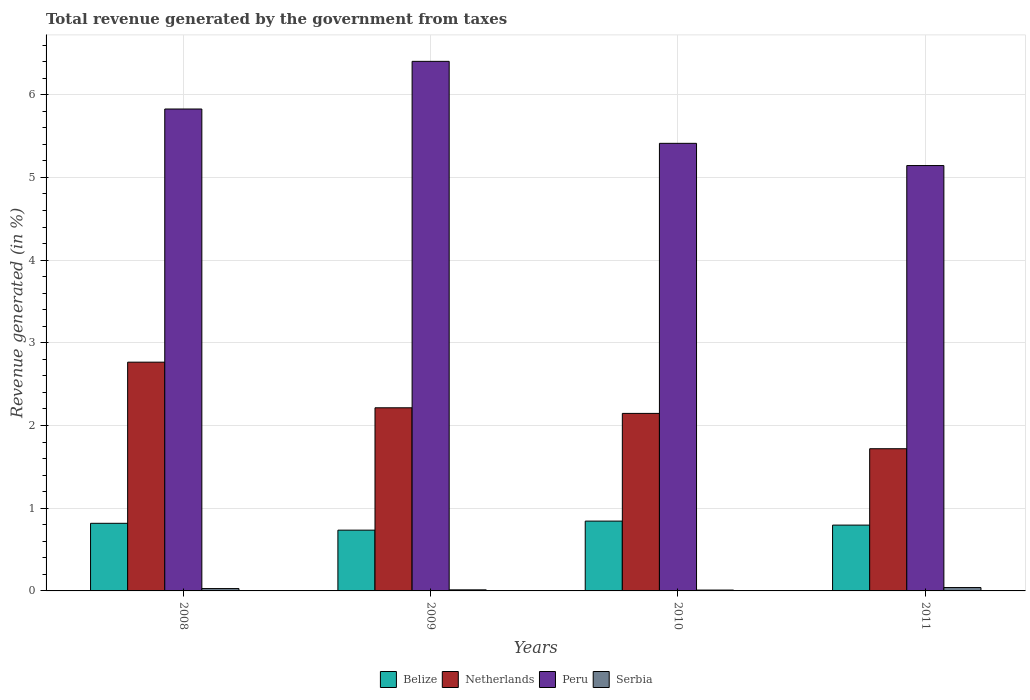How many different coloured bars are there?
Provide a short and direct response. 4. How many groups of bars are there?
Provide a succinct answer. 4. How many bars are there on the 1st tick from the left?
Provide a succinct answer. 4. What is the label of the 2nd group of bars from the left?
Make the answer very short. 2009. What is the total revenue generated in Serbia in 2008?
Provide a short and direct response. 0.03. Across all years, what is the maximum total revenue generated in Peru?
Provide a succinct answer. 6.4. Across all years, what is the minimum total revenue generated in Peru?
Offer a very short reply. 5.14. What is the total total revenue generated in Peru in the graph?
Your answer should be compact. 22.78. What is the difference between the total revenue generated in Netherlands in 2009 and that in 2011?
Provide a succinct answer. 0.49. What is the difference between the total revenue generated in Belize in 2008 and the total revenue generated in Netherlands in 2009?
Your answer should be compact. -1.4. What is the average total revenue generated in Serbia per year?
Your answer should be very brief. 0.02. In the year 2009, what is the difference between the total revenue generated in Serbia and total revenue generated in Belize?
Offer a terse response. -0.72. In how many years, is the total revenue generated in Belize greater than 6.4 %?
Your response must be concise. 0. What is the ratio of the total revenue generated in Belize in 2008 to that in 2011?
Offer a terse response. 1.03. Is the difference between the total revenue generated in Serbia in 2009 and 2011 greater than the difference between the total revenue generated in Belize in 2009 and 2011?
Provide a succinct answer. Yes. What is the difference between the highest and the second highest total revenue generated in Peru?
Your response must be concise. 0.58. What is the difference between the highest and the lowest total revenue generated in Peru?
Make the answer very short. 1.26. In how many years, is the total revenue generated in Peru greater than the average total revenue generated in Peru taken over all years?
Keep it short and to the point. 2. Is the sum of the total revenue generated in Netherlands in 2008 and 2011 greater than the maximum total revenue generated in Peru across all years?
Your answer should be very brief. No. What does the 3rd bar from the left in 2011 represents?
Provide a succinct answer. Peru. What does the 1st bar from the right in 2009 represents?
Provide a succinct answer. Serbia. Is it the case that in every year, the sum of the total revenue generated in Serbia and total revenue generated in Peru is greater than the total revenue generated in Netherlands?
Provide a short and direct response. Yes. How many bars are there?
Provide a succinct answer. 16. Are all the bars in the graph horizontal?
Offer a very short reply. No. How many years are there in the graph?
Make the answer very short. 4. What is the difference between two consecutive major ticks on the Y-axis?
Your answer should be very brief. 1. Are the values on the major ticks of Y-axis written in scientific E-notation?
Your answer should be compact. No. Does the graph contain any zero values?
Give a very brief answer. No. How many legend labels are there?
Make the answer very short. 4. What is the title of the graph?
Ensure brevity in your answer.  Total revenue generated by the government from taxes. Does "Denmark" appear as one of the legend labels in the graph?
Ensure brevity in your answer.  No. What is the label or title of the X-axis?
Make the answer very short. Years. What is the label or title of the Y-axis?
Your answer should be compact. Revenue generated (in %). What is the Revenue generated (in %) of Belize in 2008?
Offer a very short reply. 0.82. What is the Revenue generated (in %) in Netherlands in 2008?
Provide a succinct answer. 2.77. What is the Revenue generated (in %) in Peru in 2008?
Offer a very short reply. 5.83. What is the Revenue generated (in %) of Serbia in 2008?
Ensure brevity in your answer.  0.03. What is the Revenue generated (in %) of Belize in 2009?
Your response must be concise. 0.73. What is the Revenue generated (in %) of Netherlands in 2009?
Your answer should be compact. 2.21. What is the Revenue generated (in %) of Peru in 2009?
Ensure brevity in your answer.  6.4. What is the Revenue generated (in %) of Serbia in 2009?
Give a very brief answer. 0.01. What is the Revenue generated (in %) in Belize in 2010?
Your answer should be very brief. 0.84. What is the Revenue generated (in %) in Netherlands in 2010?
Your answer should be very brief. 2.15. What is the Revenue generated (in %) of Peru in 2010?
Make the answer very short. 5.41. What is the Revenue generated (in %) of Serbia in 2010?
Give a very brief answer. 0.01. What is the Revenue generated (in %) in Belize in 2011?
Give a very brief answer. 0.8. What is the Revenue generated (in %) of Netherlands in 2011?
Your answer should be very brief. 1.72. What is the Revenue generated (in %) of Peru in 2011?
Give a very brief answer. 5.14. What is the Revenue generated (in %) of Serbia in 2011?
Give a very brief answer. 0.04. Across all years, what is the maximum Revenue generated (in %) in Belize?
Offer a very short reply. 0.84. Across all years, what is the maximum Revenue generated (in %) in Netherlands?
Provide a succinct answer. 2.77. Across all years, what is the maximum Revenue generated (in %) in Peru?
Ensure brevity in your answer.  6.4. Across all years, what is the maximum Revenue generated (in %) of Serbia?
Make the answer very short. 0.04. Across all years, what is the minimum Revenue generated (in %) in Belize?
Provide a succinct answer. 0.73. Across all years, what is the minimum Revenue generated (in %) of Netherlands?
Your answer should be compact. 1.72. Across all years, what is the minimum Revenue generated (in %) of Peru?
Your answer should be compact. 5.14. Across all years, what is the minimum Revenue generated (in %) in Serbia?
Give a very brief answer. 0.01. What is the total Revenue generated (in %) in Belize in the graph?
Provide a short and direct response. 3.19. What is the total Revenue generated (in %) in Netherlands in the graph?
Provide a short and direct response. 8.85. What is the total Revenue generated (in %) in Peru in the graph?
Your answer should be compact. 22.79. What is the total Revenue generated (in %) in Serbia in the graph?
Ensure brevity in your answer.  0.09. What is the difference between the Revenue generated (in %) of Belize in 2008 and that in 2009?
Your answer should be very brief. 0.08. What is the difference between the Revenue generated (in %) of Netherlands in 2008 and that in 2009?
Make the answer very short. 0.55. What is the difference between the Revenue generated (in %) in Peru in 2008 and that in 2009?
Make the answer very short. -0.58. What is the difference between the Revenue generated (in %) in Serbia in 2008 and that in 2009?
Provide a succinct answer. 0.02. What is the difference between the Revenue generated (in %) in Belize in 2008 and that in 2010?
Offer a very short reply. -0.03. What is the difference between the Revenue generated (in %) of Netherlands in 2008 and that in 2010?
Your answer should be compact. 0.62. What is the difference between the Revenue generated (in %) in Peru in 2008 and that in 2010?
Give a very brief answer. 0.42. What is the difference between the Revenue generated (in %) in Serbia in 2008 and that in 2010?
Make the answer very short. 0.02. What is the difference between the Revenue generated (in %) of Belize in 2008 and that in 2011?
Give a very brief answer. 0.02. What is the difference between the Revenue generated (in %) of Netherlands in 2008 and that in 2011?
Make the answer very short. 1.05. What is the difference between the Revenue generated (in %) of Peru in 2008 and that in 2011?
Ensure brevity in your answer.  0.68. What is the difference between the Revenue generated (in %) in Serbia in 2008 and that in 2011?
Provide a succinct answer. -0.01. What is the difference between the Revenue generated (in %) of Belize in 2009 and that in 2010?
Ensure brevity in your answer.  -0.11. What is the difference between the Revenue generated (in %) in Netherlands in 2009 and that in 2010?
Offer a terse response. 0.07. What is the difference between the Revenue generated (in %) in Serbia in 2009 and that in 2010?
Offer a very short reply. 0. What is the difference between the Revenue generated (in %) in Belize in 2009 and that in 2011?
Provide a succinct answer. -0.06. What is the difference between the Revenue generated (in %) in Netherlands in 2009 and that in 2011?
Your answer should be compact. 0.49. What is the difference between the Revenue generated (in %) of Peru in 2009 and that in 2011?
Offer a very short reply. 1.26. What is the difference between the Revenue generated (in %) in Serbia in 2009 and that in 2011?
Keep it short and to the point. -0.03. What is the difference between the Revenue generated (in %) in Belize in 2010 and that in 2011?
Offer a terse response. 0.05. What is the difference between the Revenue generated (in %) in Netherlands in 2010 and that in 2011?
Provide a succinct answer. 0.43. What is the difference between the Revenue generated (in %) of Peru in 2010 and that in 2011?
Offer a terse response. 0.27. What is the difference between the Revenue generated (in %) of Serbia in 2010 and that in 2011?
Your response must be concise. -0.03. What is the difference between the Revenue generated (in %) of Belize in 2008 and the Revenue generated (in %) of Netherlands in 2009?
Offer a very short reply. -1.4. What is the difference between the Revenue generated (in %) of Belize in 2008 and the Revenue generated (in %) of Peru in 2009?
Your answer should be very brief. -5.59. What is the difference between the Revenue generated (in %) of Belize in 2008 and the Revenue generated (in %) of Serbia in 2009?
Offer a terse response. 0.8. What is the difference between the Revenue generated (in %) in Netherlands in 2008 and the Revenue generated (in %) in Peru in 2009?
Offer a terse response. -3.64. What is the difference between the Revenue generated (in %) of Netherlands in 2008 and the Revenue generated (in %) of Serbia in 2009?
Keep it short and to the point. 2.75. What is the difference between the Revenue generated (in %) of Peru in 2008 and the Revenue generated (in %) of Serbia in 2009?
Keep it short and to the point. 5.81. What is the difference between the Revenue generated (in %) of Belize in 2008 and the Revenue generated (in %) of Netherlands in 2010?
Offer a terse response. -1.33. What is the difference between the Revenue generated (in %) in Belize in 2008 and the Revenue generated (in %) in Peru in 2010?
Give a very brief answer. -4.59. What is the difference between the Revenue generated (in %) in Belize in 2008 and the Revenue generated (in %) in Serbia in 2010?
Offer a terse response. 0.81. What is the difference between the Revenue generated (in %) in Netherlands in 2008 and the Revenue generated (in %) in Peru in 2010?
Make the answer very short. -2.65. What is the difference between the Revenue generated (in %) in Netherlands in 2008 and the Revenue generated (in %) in Serbia in 2010?
Give a very brief answer. 2.76. What is the difference between the Revenue generated (in %) in Peru in 2008 and the Revenue generated (in %) in Serbia in 2010?
Ensure brevity in your answer.  5.82. What is the difference between the Revenue generated (in %) of Belize in 2008 and the Revenue generated (in %) of Netherlands in 2011?
Keep it short and to the point. -0.9. What is the difference between the Revenue generated (in %) of Belize in 2008 and the Revenue generated (in %) of Peru in 2011?
Keep it short and to the point. -4.33. What is the difference between the Revenue generated (in %) of Belize in 2008 and the Revenue generated (in %) of Serbia in 2011?
Provide a succinct answer. 0.78. What is the difference between the Revenue generated (in %) of Netherlands in 2008 and the Revenue generated (in %) of Peru in 2011?
Keep it short and to the point. -2.38. What is the difference between the Revenue generated (in %) of Netherlands in 2008 and the Revenue generated (in %) of Serbia in 2011?
Provide a short and direct response. 2.73. What is the difference between the Revenue generated (in %) in Peru in 2008 and the Revenue generated (in %) in Serbia in 2011?
Give a very brief answer. 5.79. What is the difference between the Revenue generated (in %) of Belize in 2009 and the Revenue generated (in %) of Netherlands in 2010?
Offer a very short reply. -1.41. What is the difference between the Revenue generated (in %) of Belize in 2009 and the Revenue generated (in %) of Peru in 2010?
Ensure brevity in your answer.  -4.68. What is the difference between the Revenue generated (in %) of Belize in 2009 and the Revenue generated (in %) of Serbia in 2010?
Provide a succinct answer. 0.72. What is the difference between the Revenue generated (in %) of Netherlands in 2009 and the Revenue generated (in %) of Peru in 2010?
Provide a succinct answer. -3.2. What is the difference between the Revenue generated (in %) of Netherlands in 2009 and the Revenue generated (in %) of Serbia in 2010?
Give a very brief answer. 2.2. What is the difference between the Revenue generated (in %) of Peru in 2009 and the Revenue generated (in %) of Serbia in 2010?
Your answer should be compact. 6.39. What is the difference between the Revenue generated (in %) in Belize in 2009 and the Revenue generated (in %) in Netherlands in 2011?
Offer a very short reply. -0.98. What is the difference between the Revenue generated (in %) of Belize in 2009 and the Revenue generated (in %) of Peru in 2011?
Your response must be concise. -4.41. What is the difference between the Revenue generated (in %) of Belize in 2009 and the Revenue generated (in %) of Serbia in 2011?
Ensure brevity in your answer.  0.69. What is the difference between the Revenue generated (in %) of Netherlands in 2009 and the Revenue generated (in %) of Peru in 2011?
Your answer should be compact. -2.93. What is the difference between the Revenue generated (in %) in Netherlands in 2009 and the Revenue generated (in %) in Serbia in 2011?
Your answer should be compact. 2.17. What is the difference between the Revenue generated (in %) of Peru in 2009 and the Revenue generated (in %) of Serbia in 2011?
Keep it short and to the point. 6.36. What is the difference between the Revenue generated (in %) of Belize in 2010 and the Revenue generated (in %) of Netherlands in 2011?
Your answer should be very brief. -0.88. What is the difference between the Revenue generated (in %) of Belize in 2010 and the Revenue generated (in %) of Peru in 2011?
Provide a short and direct response. -4.3. What is the difference between the Revenue generated (in %) of Belize in 2010 and the Revenue generated (in %) of Serbia in 2011?
Provide a short and direct response. 0.8. What is the difference between the Revenue generated (in %) of Netherlands in 2010 and the Revenue generated (in %) of Peru in 2011?
Ensure brevity in your answer.  -3. What is the difference between the Revenue generated (in %) of Netherlands in 2010 and the Revenue generated (in %) of Serbia in 2011?
Your answer should be compact. 2.11. What is the difference between the Revenue generated (in %) in Peru in 2010 and the Revenue generated (in %) in Serbia in 2011?
Keep it short and to the point. 5.37. What is the average Revenue generated (in %) in Belize per year?
Your response must be concise. 0.8. What is the average Revenue generated (in %) in Netherlands per year?
Offer a very short reply. 2.21. What is the average Revenue generated (in %) in Peru per year?
Your answer should be very brief. 5.7. What is the average Revenue generated (in %) of Serbia per year?
Your answer should be very brief. 0.02. In the year 2008, what is the difference between the Revenue generated (in %) of Belize and Revenue generated (in %) of Netherlands?
Make the answer very short. -1.95. In the year 2008, what is the difference between the Revenue generated (in %) in Belize and Revenue generated (in %) in Peru?
Give a very brief answer. -5.01. In the year 2008, what is the difference between the Revenue generated (in %) in Belize and Revenue generated (in %) in Serbia?
Make the answer very short. 0.79. In the year 2008, what is the difference between the Revenue generated (in %) in Netherlands and Revenue generated (in %) in Peru?
Keep it short and to the point. -3.06. In the year 2008, what is the difference between the Revenue generated (in %) of Netherlands and Revenue generated (in %) of Serbia?
Your answer should be very brief. 2.74. In the year 2008, what is the difference between the Revenue generated (in %) in Peru and Revenue generated (in %) in Serbia?
Offer a very short reply. 5.8. In the year 2009, what is the difference between the Revenue generated (in %) in Belize and Revenue generated (in %) in Netherlands?
Your answer should be compact. -1.48. In the year 2009, what is the difference between the Revenue generated (in %) of Belize and Revenue generated (in %) of Peru?
Your response must be concise. -5.67. In the year 2009, what is the difference between the Revenue generated (in %) in Belize and Revenue generated (in %) in Serbia?
Keep it short and to the point. 0.72. In the year 2009, what is the difference between the Revenue generated (in %) in Netherlands and Revenue generated (in %) in Peru?
Offer a terse response. -4.19. In the year 2009, what is the difference between the Revenue generated (in %) of Netherlands and Revenue generated (in %) of Serbia?
Offer a terse response. 2.2. In the year 2009, what is the difference between the Revenue generated (in %) of Peru and Revenue generated (in %) of Serbia?
Provide a short and direct response. 6.39. In the year 2010, what is the difference between the Revenue generated (in %) in Belize and Revenue generated (in %) in Netherlands?
Ensure brevity in your answer.  -1.3. In the year 2010, what is the difference between the Revenue generated (in %) of Belize and Revenue generated (in %) of Peru?
Your answer should be compact. -4.57. In the year 2010, what is the difference between the Revenue generated (in %) of Belize and Revenue generated (in %) of Serbia?
Your response must be concise. 0.83. In the year 2010, what is the difference between the Revenue generated (in %) of Netherlands and Revenue generated (in %) of Peru?
Keep it short and to the point. -3.27. In the year 2010, what is the difference between the Revenue generated (in %) of Netherlands and Revenue generated (in %) of Serbia?
Your answer should be very brief. 2.14. In the year 2010, what is the difference between the Revenue generated (in %) in Peru and Revenue generated (in %) in Serbia?
Ensure brevity in your answer.  5.4. In the year 2011, what is the difference between the Revenue generated (in %) of Belize and Revenue generated (in %) of Netherlands?
Your answer should be very brief. -0.92. In the year 2011, what is the difference between the Revenue generated (in %) of Belize and Revenue generated (in %) of Peru?
Your response must be concise. -4.35. In the year 2011, what is the difference between the Revenue generated (in %) in Belize and Revenue generated (in %) in Serbia?
Keep it short and to the point. 0.76. In the year 2011, what is the difference between the Revenue generated (in %) in Netherlands and Revenue generated (in %) in Peru?
Provide a succinct answer. -3.42. In the year 2011, what is the difference between the Revenue generated (in %) in Netherlands and Revenue generated (in %) in Serbia?
Keep it short and to the point. 1.68. In the year 2011, what is the difference between the Revenue generated (in %) in Peru and Revenue generated (in %) in Serbia?
Your answer should be very brief. 5.1. What is the ratio of the Revenue generated (in %) in Belize in 2008 to that in 2009?
Provide a succinct answer. 1.11. What is the ratio of the Revenue generated (in %) in Netherlands in 2008 to that in 2009?
Offer a very short reply. 1.25. What is the ratio of the Revenue generated (in %) in Peru in 2008 to that in 2009?
Offer a terse response. 0.91. What is the ratio of the Revenue generated (in %) of Serbia in 2008 to that in 2009?
Your answer should be very brief. 2.18. What is the ratio of the Revenue generated (in %) in Belize in 2008 to that in 2010?
Provide a short and direct response. 0.97. What is the ratio of the Revenue generated (in %) in Netherlands in 2008 to that in 2010?
Provide a short and direct response. 1.29. What is the ratio of the Revenue generated (in %) in Peru in 2008 to that in 2010?
Ensure brevity in your answer.  1.08. What is the ratio of the Revenue generated (in %) in Serbia in 2008 to that in 2010?
Offer a terse response. 2.74. What is the ratio of the Revenue generated (in %) in Belize in 2008 to that in 2011?
Keep it short and to the point. 1.03. What is the ratio of the Revenue generated (in %) in Netherlands in 2008 to that in 2011?
Provide a short and direct response. 1.61. What is the ratio of the Revenue generated (in %) in Peru in 2008 to that in 2011?
Keep it short and to the point. 1.13. What is the ratio of the Revenue generated (in %) in Serbia in 2008 to that in 2011?
Your answer should be compact. 0.7. What is the ratio of the Revenue generated (in %) in Belize in 2009 to that in 2010?
Your answer should be compact. 0.87. What is the ratio of the Revenue generated (in %) of Netherlands in 2009 to that in 2010?
Offer a terse response. 1.03. What is the ratio of the Revenue generated (in %) in Peru in 2009 to that in 2010?
Your answer should be very brief. 1.18. What is the ratio of the Revenue generated (in %) in Serbia in 2009 to that in 2010?
Offer a very short reply. 1.25. What is the ratio of the Revenue generated (in %) of Netherlands in 2009 to that in 2011?
Offer a terse response. 1.29. What is the ratio of the Revenue generated (in %) of Peru in 2009 to that in 2011?
Ensure brevity in your answer.  1.24. What is the ratio of the Revenue generated (in %) of Serbia in 2009 to that in 2011?
Your answer should be compact. 0.32. What is the ratio of the Revenue generated (in %) in Belize in 2010 to that in 2011?
Make the answer very short. 1.06. What is the ratio of the Revenue generated (in %) in Netherlands in 2010 to that in 2011?
Make the answer very short. 1.25. What is the ratio of the Revenue generated (in %) in Peru in 2010 to that in 2011?
Your answer should be very brief. 1.05. What is the ratio of the Revenue generated (in %) of Serbia in 2010 to that in 2011?
Offer a very short reply. 0.26. What is the difference between the highest and the second highest Revenue generated (in %) of Belize?
Offer a very short reply. 0.03. What is the difference between the highest and the second highest Revenue generated (in %) in Netherlands?
Keep it short and to the point. 0.55. What is the difference between the highest and the second highest Revenue generated (in %) in Peru?
Offer a very short reply. 0.58. What is the difference between the highest and the second highest Revenue generated (in %) in Serbia?
Ensure brevity in your answer.  0.01. What is the difference between the highest and the lowest Revenue generated (in %) in Belize?
Provide a succinct answer. 0.11. What is the difference between the highest and the lowest Revenue generated (in %) of Netherlands?
Your response must be concise. 1.05. What is the difference between the highest and the lowest Revenue generated (in %) in Peru?
Your answer should be compact. 1.26. What is the difference between the highest and the lowest Revenue generated (in %) of Serbia?
Your answer should be very brief. 0.03. 